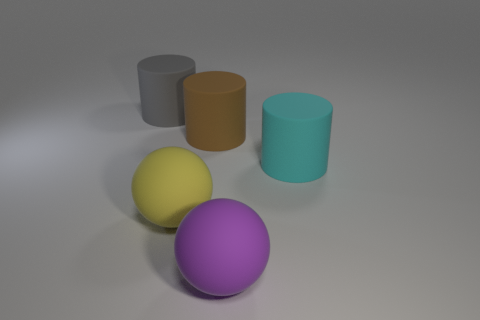Add 4 cylinders. How many objects exist? 9 Subtract all spheres. How many objects are left? 3 Add 1 yellow matte cubes. How many yellow matte cubes exist? 1 Subtract 0 blue cylinders. How many objects are left? 5 Subtract all brown objects. Subtract all big brown cylinders. How many objects are left? 3 Add 4 brown cylinders. How many brown cylinders are left? 5 